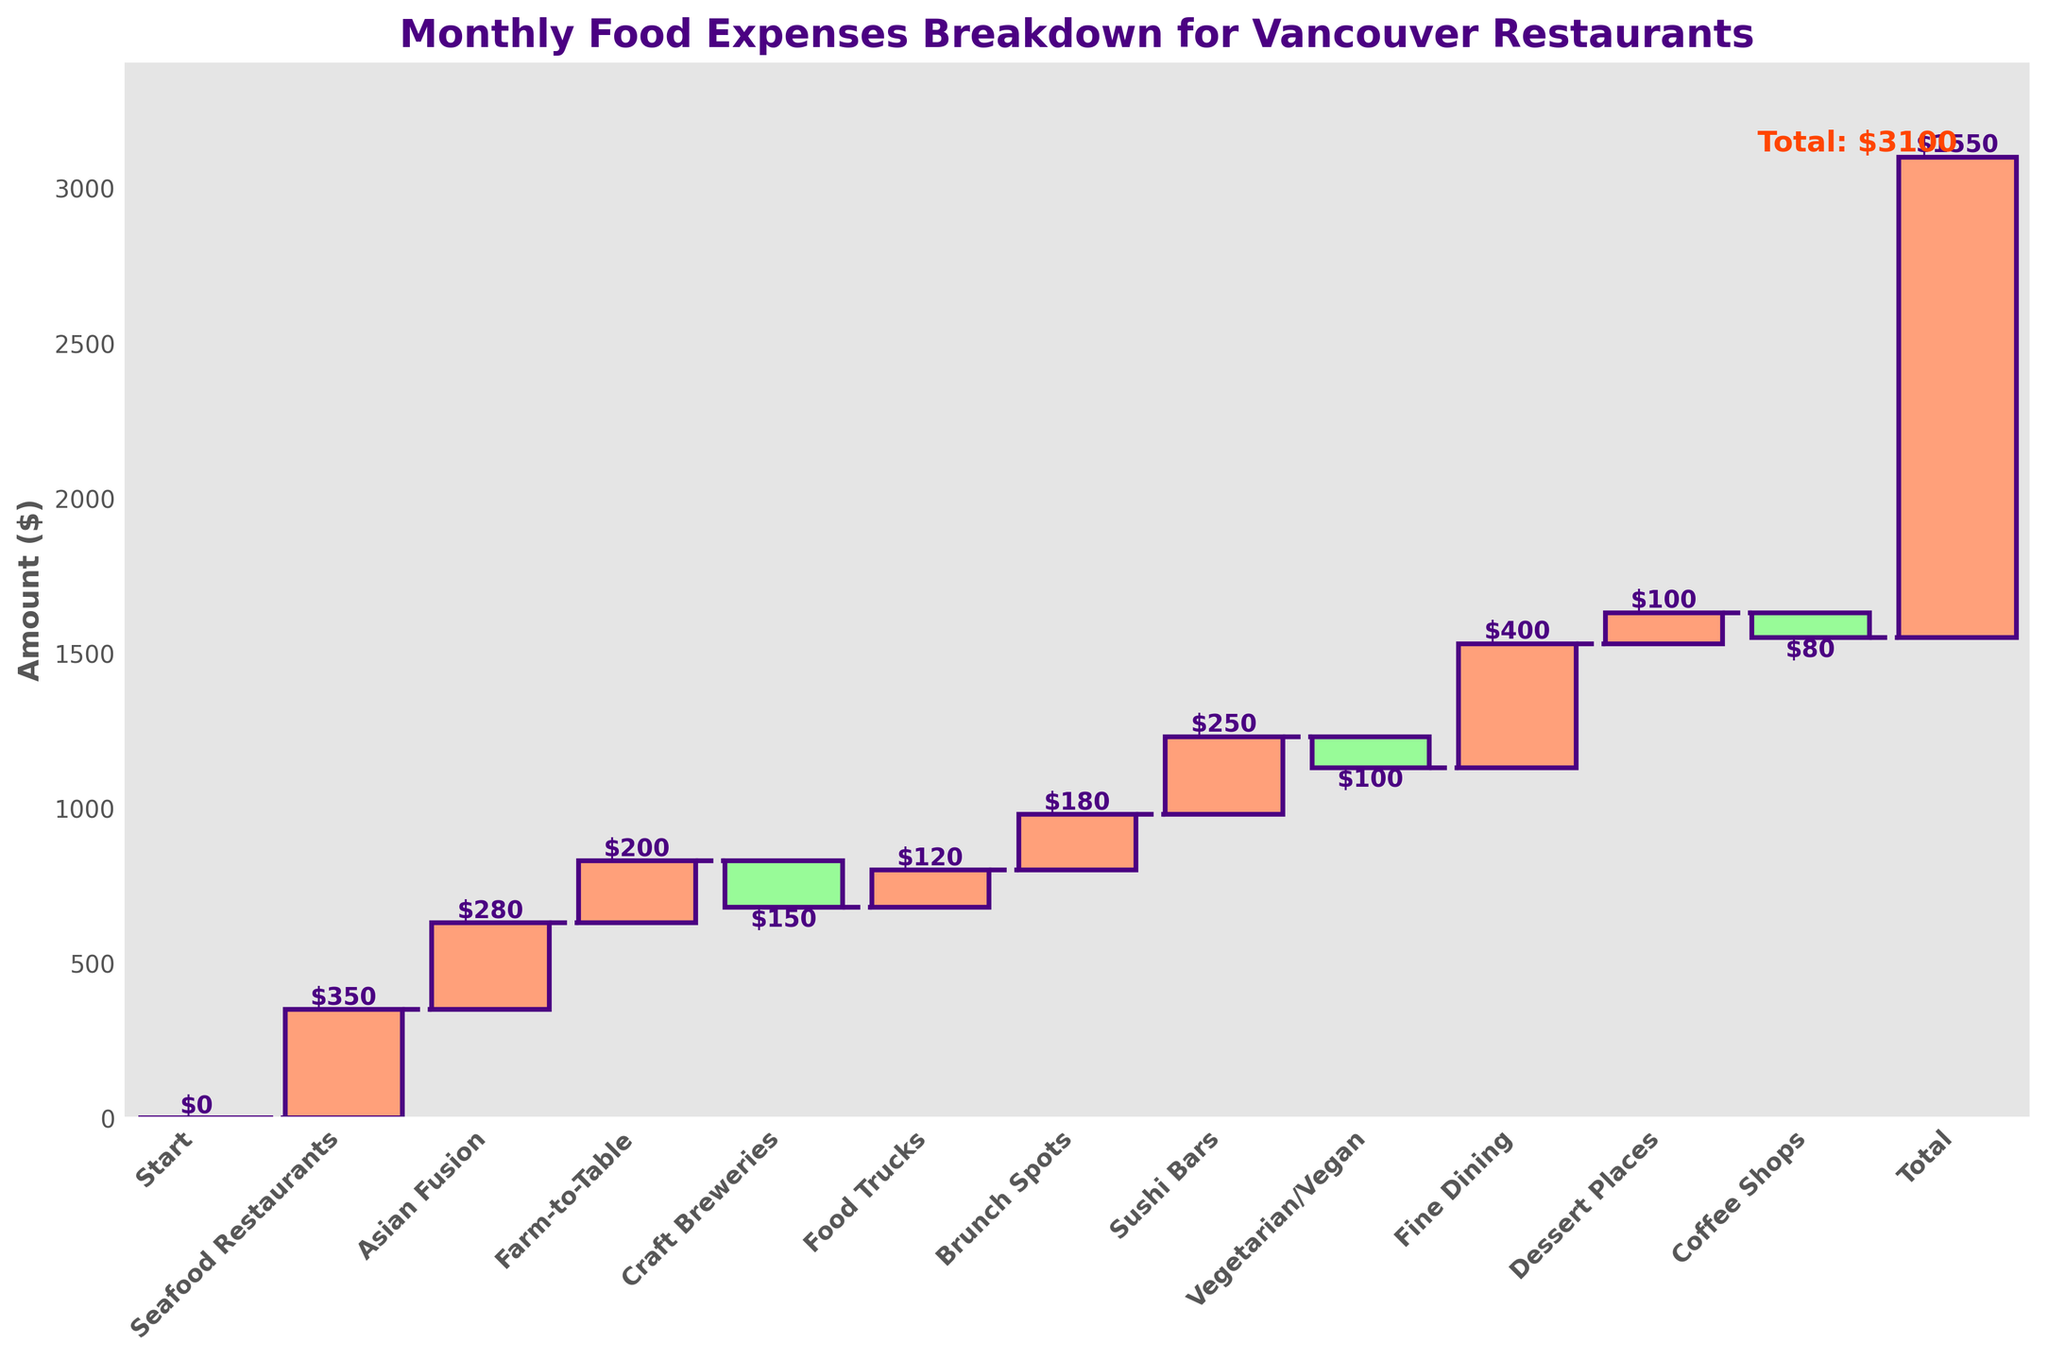What is the title of the chart? The title of the chart is displayed at the top of the figure and it reads "Monthly Food Expenses Breakdown for Vancouver Restaurants".
Answer: Monthly Food Expenses Breakdown for Vancouver Restaurants How many categories are represented in the chart? The chart includes all the bars starting from "Start" to the "Total", and there are 12 bars.
Answer: 12 What is the total amount spent on food in Vancouver restaurants for the month? The total amount is shown at the last bar of the chart, labeled "Total". The cumulative value reached is $1550.
Answer: $1550 Which category has the highest expense amount? The highest bar on the chart represents the highest expense category. Fine Dining has a bar height of $400, making it the highest.
Answer: Fine Dining How much was spent on Coffee Shops? The value labeled on the Coffee Shops bar indicates the amount spent, which is -$80.
Answer: -$80 What are the two categories with negative expenses? The bars that are green color represent negative expenses. Craft Breweries and Coffee Shops both have negative expenses: -$150 for Craft Breweries and -$80 for Coffee Shops.
Answer: Craft Breweries, Coffee Shops How much more was spent on Seafood Restaurants compared to Farm-to-Table? From the chart, Seafood Restaurants show $350 and Farm-to-Table shows $200. The difference is calculated by subtracting Farm-to-Table from Seafood Restaurants: $350 - $200 = $150.
Answer: $150 What is the sum of expenses for Asian Fusion and Sushi Bars? The expenses for Asian Fusion and Sushi Bars are $280 and $250 respectively. Adding them: $280 + $250 = $530.
Answer: $530 Which category is positioned exactly in the middle of the chart, and what is its expense value? Counting the categories from start to end, the middle category is Food Trucks which has a value of $120.
Answer: Food Trucks, $120 What would be the new total if Vegetarian/Vegan expenses were reduced by an additional $50? Currently, Vegetarian/Vegan is at -$100. Reducing it by an additional $50 results in -$150. Adjusting the original total ($1550) by subtracting $50 yields $1500.
Answer: $1500 